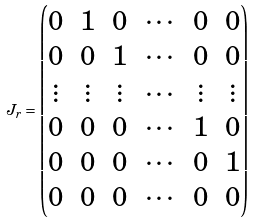<formula> <loc_0><loc_0><loc_500><loc_500>J _ { r } = \begin{pmatrix} 0 & 1 & 0 & \cdots & 0 & 0 \\ 0 & 0 & 1 & \cdots & 0 & 0 \\ \vdots & \vdots & \vdots & \cdots & \vdots & \vdots \\ 0 & 0 & 0 & \cdots & 1 & 0 \\ 0 & 0 & 0 & \cdots & 0 & 1 \\ 0 & 0 & 0 & \cdots & 0 & 0 \\ \end{pmatrix}</formula> 